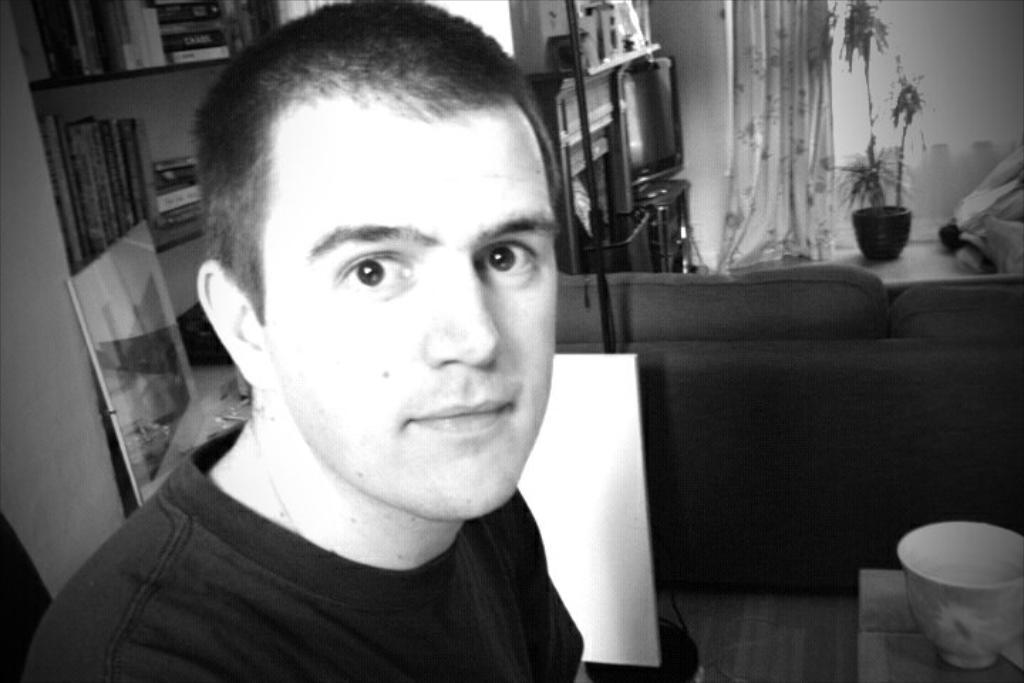In one or two sentences, can you explain what this image depicts? In this picture there is a man on the left side of the image and there is a television, rack, sofa and a plant pot in the background area of the image and there is a book shelf and curtain in the image. 